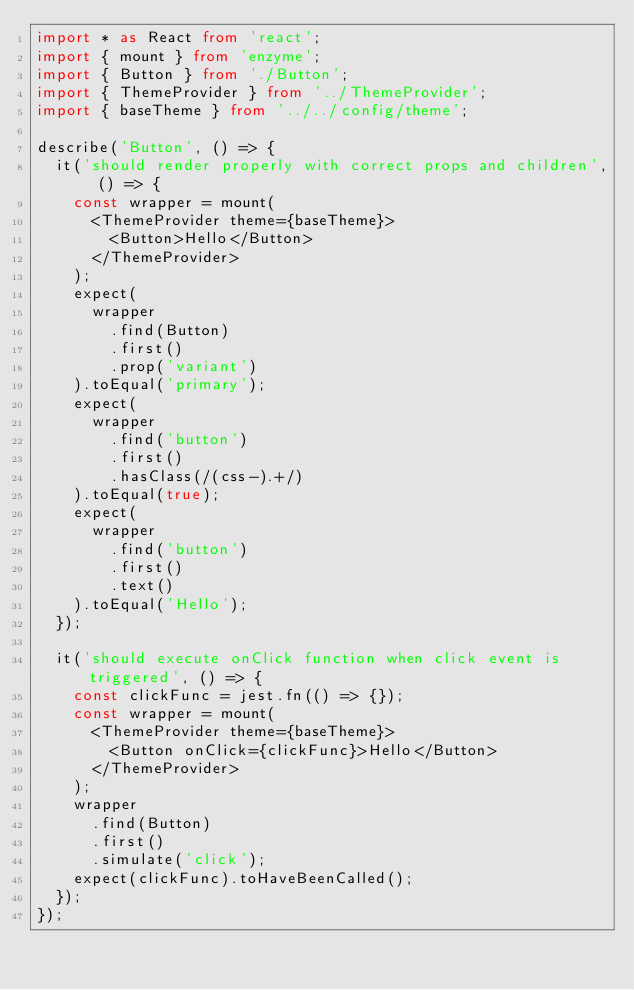<code> <loc_0><loc_0><loc_500><loc_500><_TypeScript_>import * as React from 'react';
import { mount } from 'enzyme';
import { Button } from './Button';
import { ThemeProvider } from '../ThemeProvider';
import { baseTheme } from '../../config/theme';

describe('Button', () => {
  it('should render properly with correct props and children', () => {
    const wrapper = mount(
      <ThemeProvider theme={baseTheme}>
        <Button>Hello</Button>
      </ThemeProvider>
    );
    expect(
      wrapper
        .find(Button)
        .first()
        .prop('variant')
    ).toEqual('primary');
    expect(
      wrapper
        .find('button')
        .first()
        .hasClass(/(css-).+/)
    ).toEqual(true);
    expect(
      wrapper
        .find('button')
        .first()
        .text()
    ).toEqual('Hello');
  });

  it('should execute onClick function when click event is triggered', () => {
    const clickFunc = jest.fn(() => {});
    const wrapper = mount(
      <ThemeProvider theme={baseTheme}>
        <Button onClick={clickFunc}>Hello</Button>
      </ThemeProvider>
    );
    wrapper
      .find(Button)
      .first()
      .simulate('click');
    expect(clickFunc).toHaveBeenCalled();
  });
});
</code> 